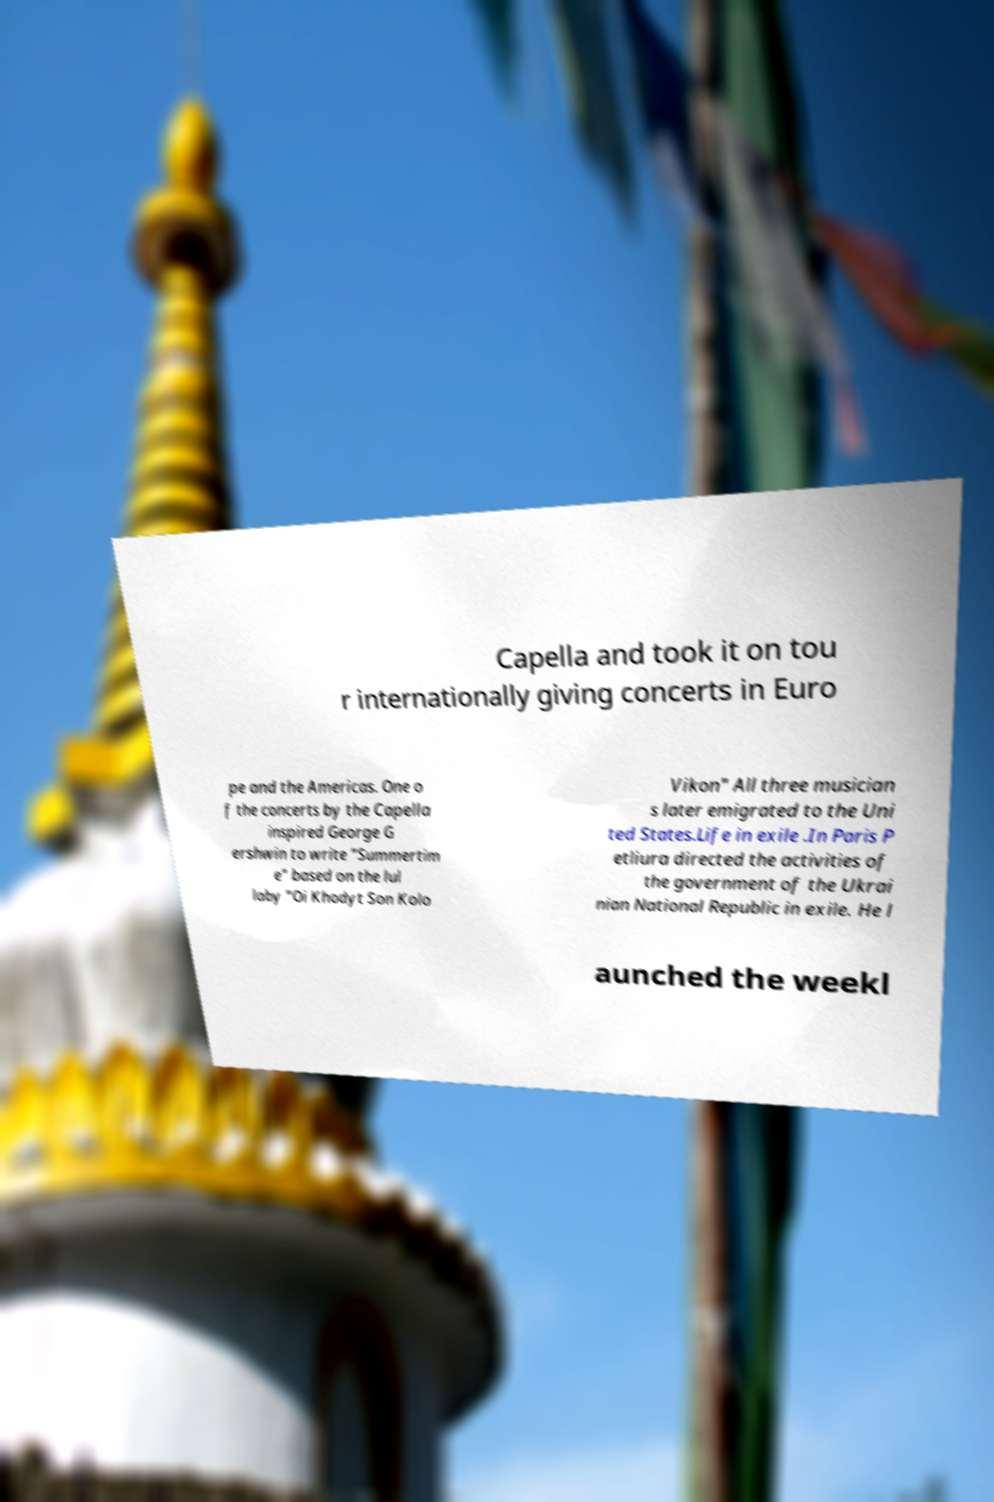I need the written content from this picture converted into text. Can you do that? Capella and took it on tou r internationally giving concerts in Euro pe and the Americas. One o f the concerts by the Capella inspired George G ershwin to write "Summertim e" based on the lul laby "Oi Khodyt Son Kolo Vikon" All three musician s later emigrated to the Uni ted States.Life in exile .In Paris P etliura directed the activities of the government of the Ukrai nian National Republic in exile. He l aunched the weekl 